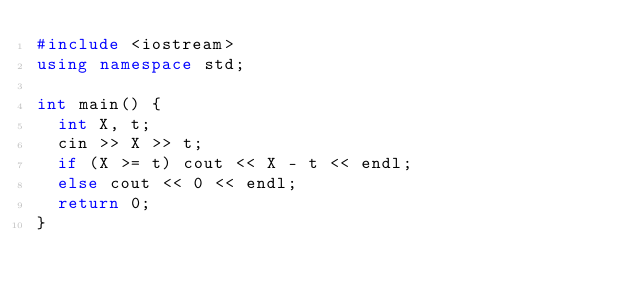Convert code to text. <code><loc_0><loc_0><loc_500><loc_500><_C++_>#include <iostream>
using namespace std;

int main() {
  int X, t;
  cin >> X >> t;
  if (X >= t) cout << X - t << endl;
  else cout << 0 << endl;
  return 0;
}</code> 